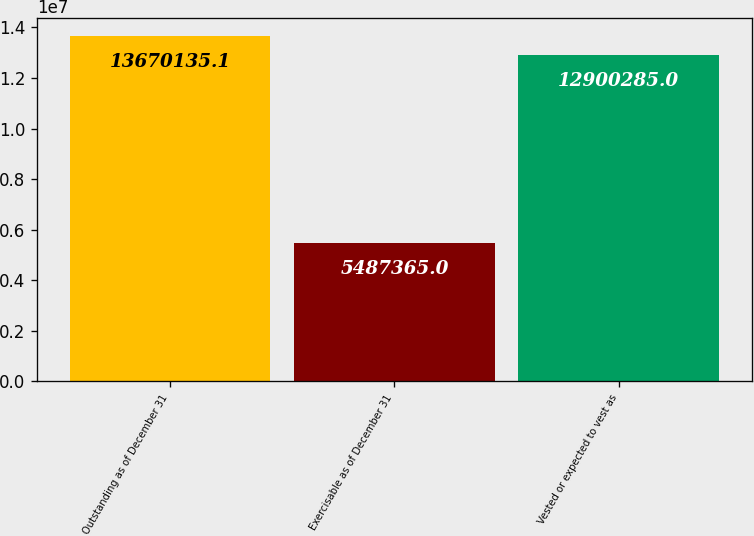Convert chart. <chart><loc_0><loc_0><loc_500><loc_500><bar_chart><fcel>Outstanding as of December 31<fcel>Exercisable as of December 31<fcel>Vested or expected to vest as<nl><fcel>1.36701e+07<fcel>5.48736e+06<fcel>1.29003e+07<nl></chart> 